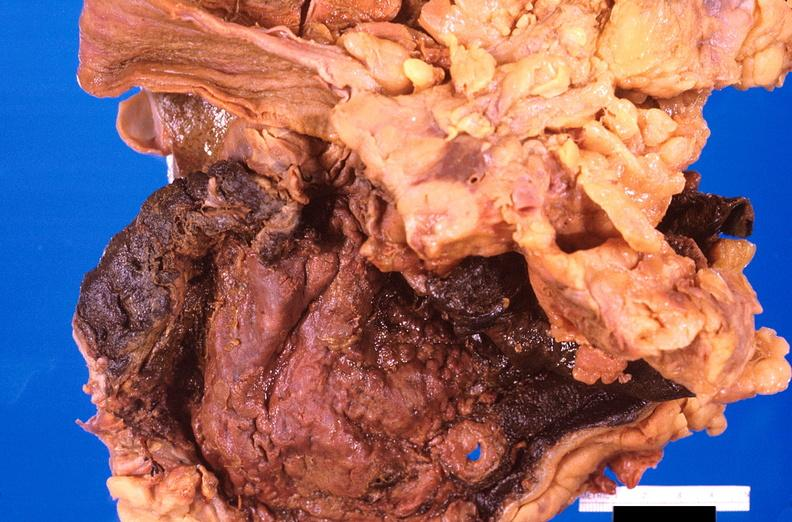does this image show stomach, necrotizing esophagitis and gastritis, sulfuric acid ingested as suicide attempt?
Answer the question using a single word or phrase. Yes 